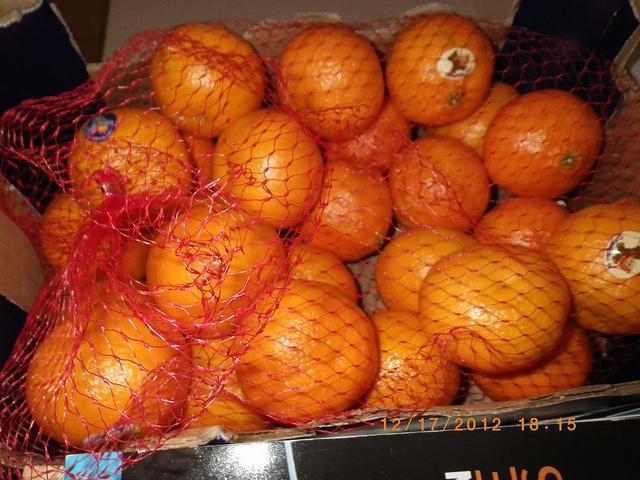How many oranges are visible?
Give a very brief answer. 6. How many people are wearing white hat?
Give a very brief answer. 0. 